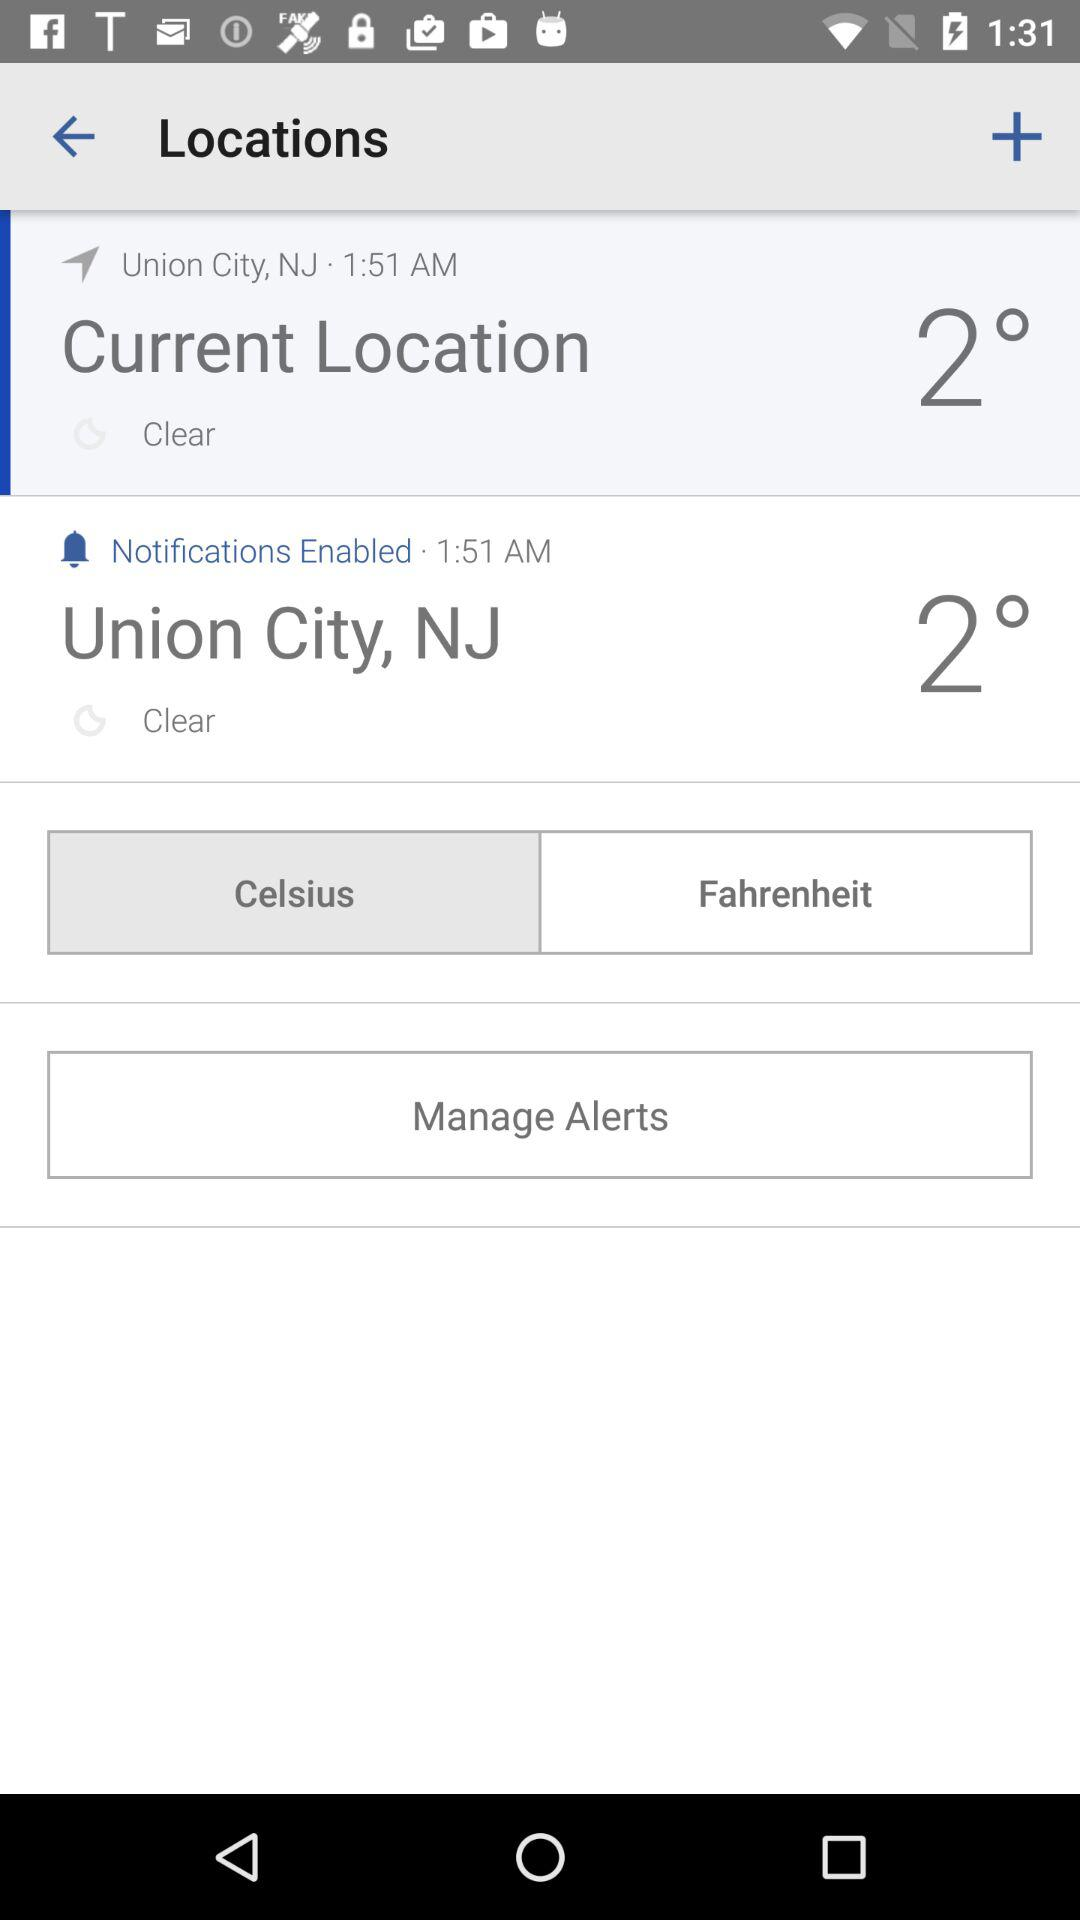What option is selected for the unit of temperature? The selected option is Celsius. 